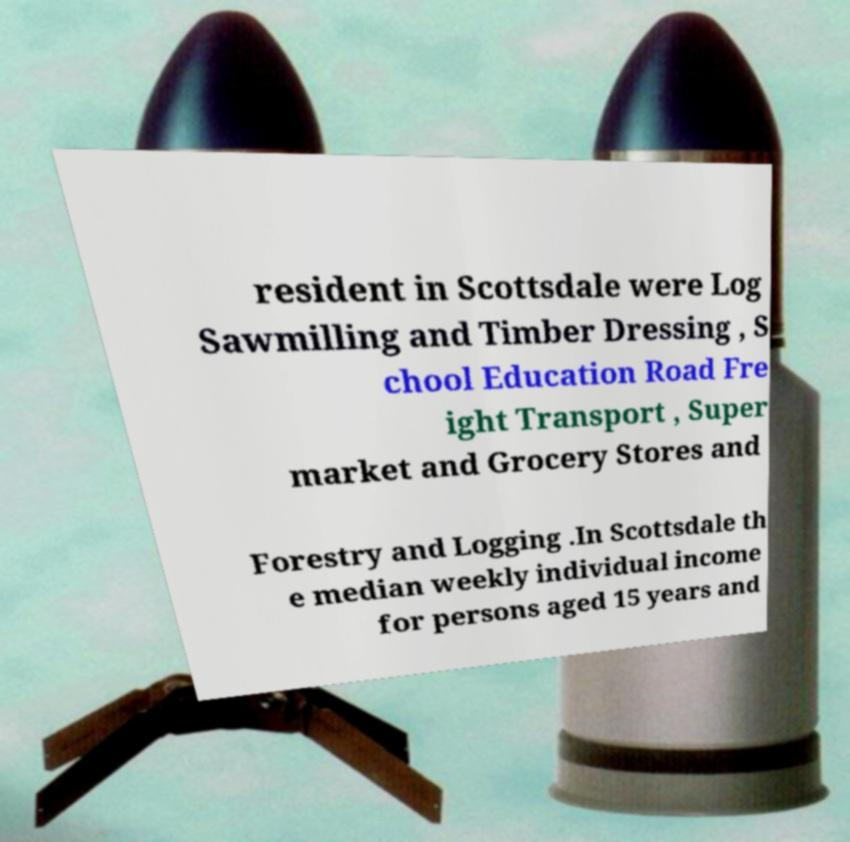I need the written content from this picture converted into text. Can you do that? resident in Scottsdale were Log Sawmilling and Timber Dressing , S chool Education Road Fre ight Transport , Super market and Grocery Stores and Forestry and Logging .In Scottsdale th e median weekly individual income for persons aged 15 years and 